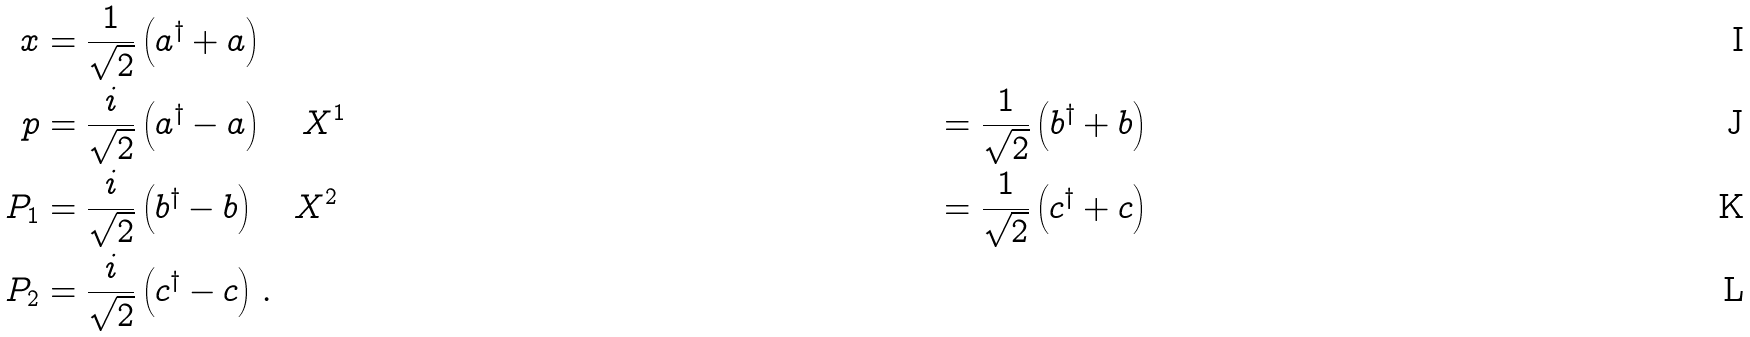Convert formula to latex. <formula><loc_0><loc_0><loc_500><loc_500>x & = \frac { 1 } { \sqrt { 2 } } \left ( a ^ { \dag } + a \right ) \\ p & = \frac { i } { \sqrt { 2 } } \left ( a ^ { \dag } - a \right ) \quad X ^ { 1 } & = \frac { 1 } { \sqrt { 2 } } \left ( b ^ { \dag } + b \right ) \\ P _ { 1 } & = \frac { i } { \sqrt { 2 } } \left ( b ^ { \dag } - b \right ) \quad X ^ { 2 } & = \frac { 1 } { \sqrt { 2 } } \left ( c ^ { \dag } + c \right ) \\ P _ { 2 } & = \frac { i } { \sqrt { 2 } } \left ( c ^ { \dag } - c \right ) \, .</formula> 